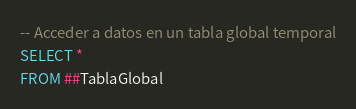Convert code to text. <code><loc_0><loc_0><loc_500><loc_500><_SQL_>-- Acceder a datos en un tabla global temporal
SELECT * 
FROM ##TablaGlobal</code> 